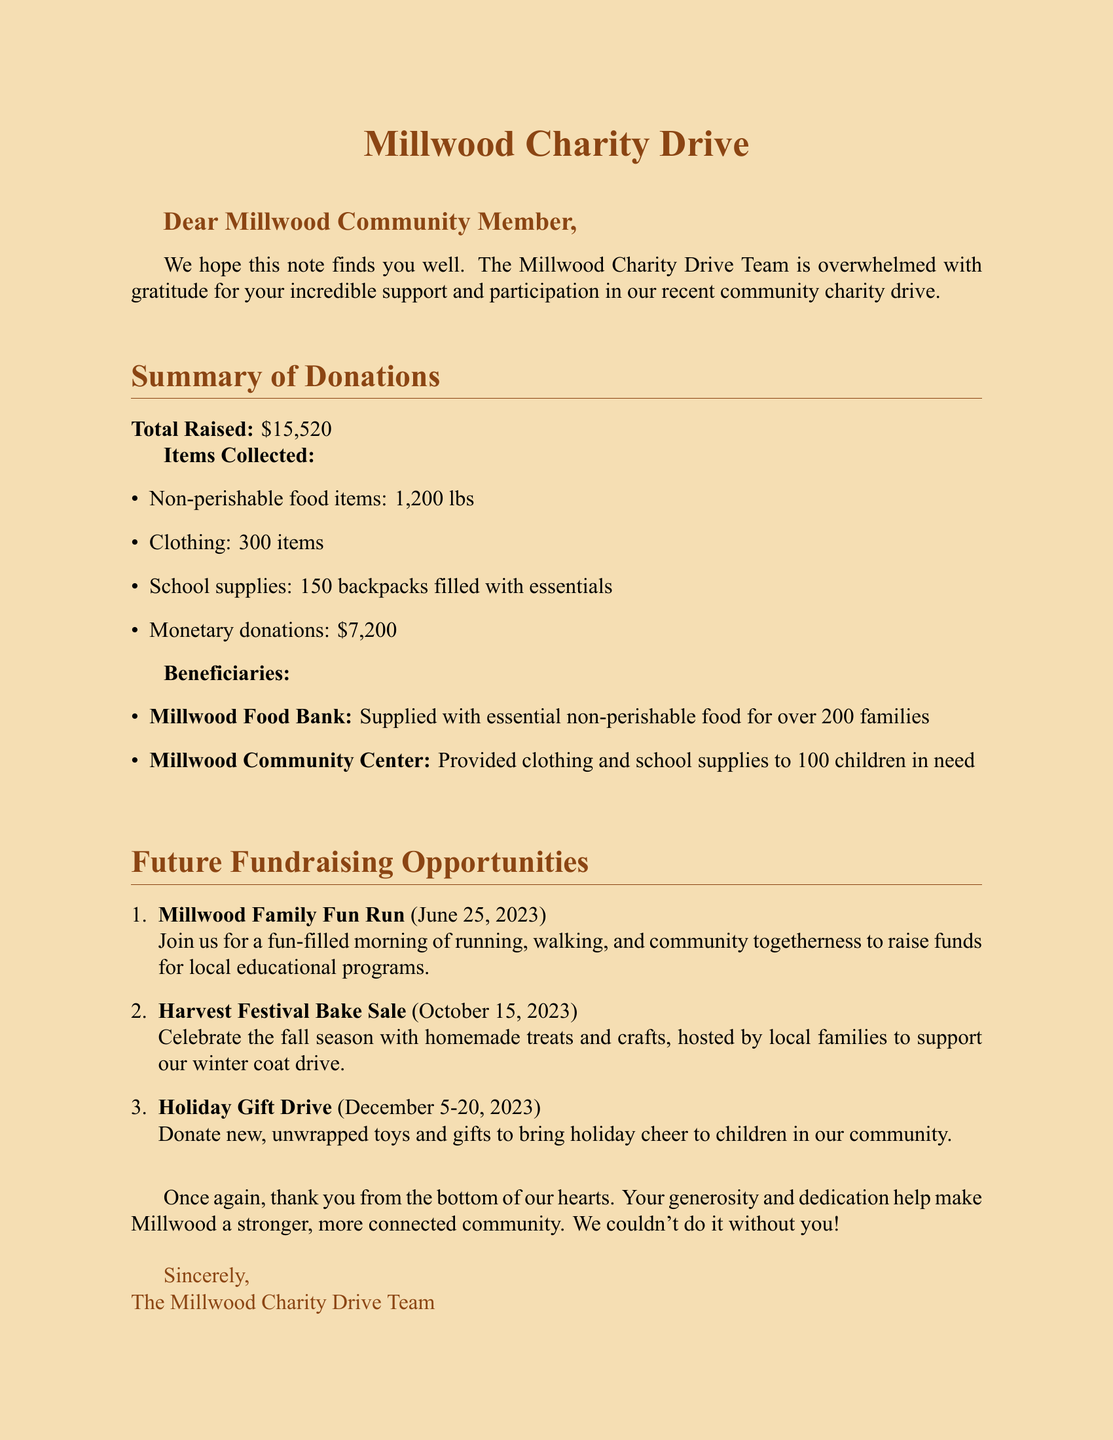what is the total amount raised from the charity drive? The total amount raised is clearly stated in the document.
Answer: $15,520 how many pounds of non-perishable food items were collected? The document lists the quantity of non-perishable food items collected.
Answer: 1,200 lbs what date is the Millwood Family Fun Run scheduled for? The date for the Millwood Family Fun Run is mentioned in the events section.
Answer: June 25, 2023 how many children benefited from clothing and school supplies? The number of children who received these supplies is provided in the beneficiaries section.
Answer: 100 children what is the purpose of the Holiday Gift Drive? The document specifies the intention behind the Holiday Gift Drive.
Answer: To bring holiday cheer to children in our community what was the monetary donations amount? The amount of monetary donations is detailed in the summary of donations.
Answer: $7,200 which charity is receiving the non-perishable food items? The specific charity that receives the food items is noted in the document.
Answer: Millwood Food Bank when will the Harvest Festival Bake Sale take place? The date of the bake sale is provided under future fundraising opportunities.
Answer: October 15, 2023 who wrote the thank you note? The document identifies the authors of the note.
Answer: The Millwood Charity Drive Team 